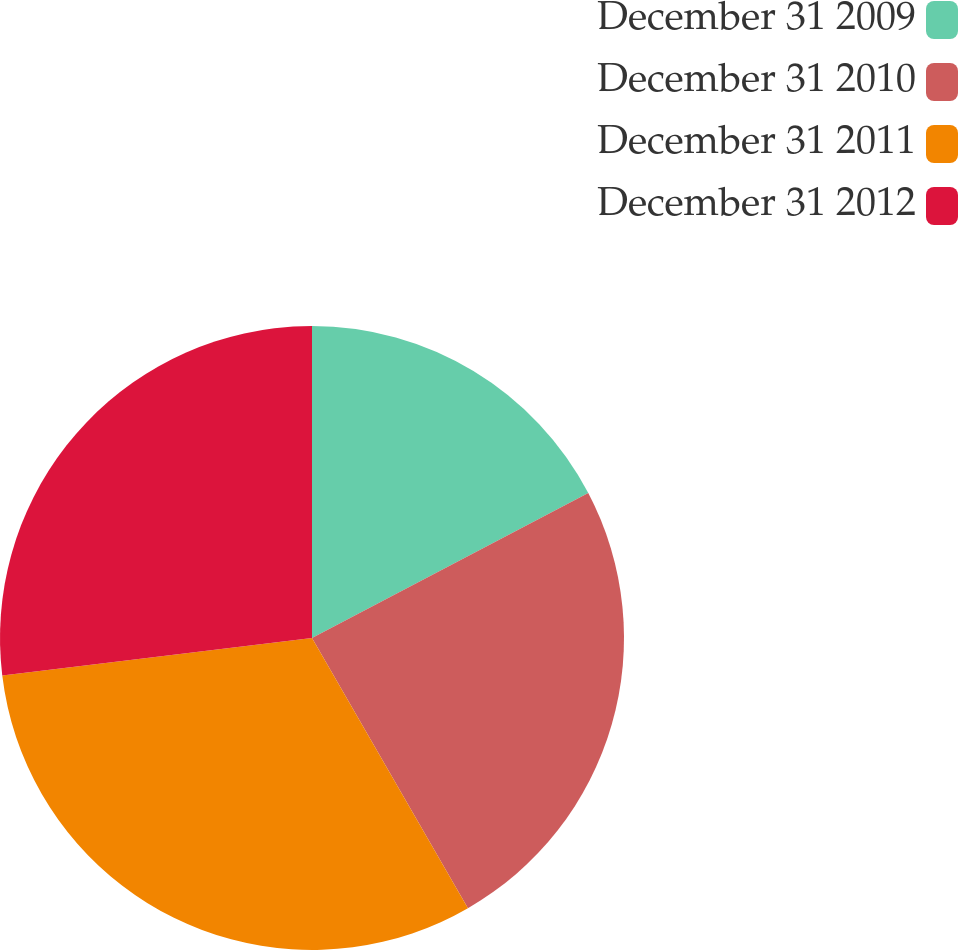Convert chart. <chart><loc_0><loc_0><loc_500><loc_500><pie_chart><fcel>December 31 2009<fcel>December 31 2010<fcel>December 31 2011<fcel>December 31 2012<nl><fcel>17.31%<fcel>24.36%<fcel>31.41%<fcel>26.92%<nl></chart> 